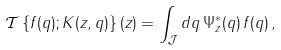Convert formula to latex. <formula><loc_0><loc_0><loc_500><loc_500>{ \mathcal { T } } \left \{ f ( q ) ; K ( z , q ) \right \} ( z ) = \int _ { \mathcal { J } } d q \, \Psi _ { z } ^ { * } ( q ) \, f ( q ) \, ,</formula> 